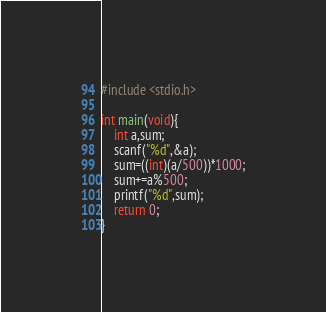<code> <loc_0><loc_0><loc_500><loc_500><_C_>#include <stdio.h>

int main(void){
    int a,sum;
    scanf("%d",&a);
    sum=((int)(a/500))*1000;
    sum+=a%500;
    printf("%d",sum);
    return 0;
}</code> 